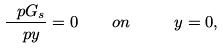<formula> <loc_0><loc_0><loc_500><loc_500>\frac { \ p G _ { s } } { \ p y } = 0 \quad o n \ \quad y = 0 ,</formula> 